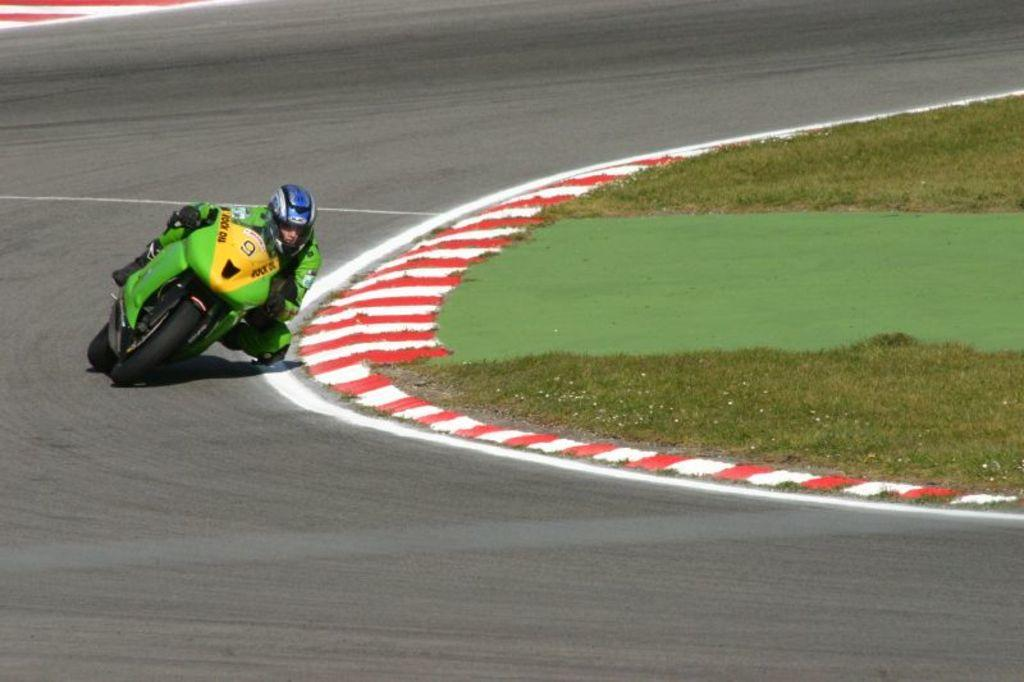What is the person in the image doing? The person is riding a motorcycle in the image. What protective gear is the person wearing? The person is wearing a helmet and gloves. What type of surface is the motorcycle on? The motorcycle is on the road. What can be seen on the ground in the image? There is grass on the ground. How many sheep are visible in the image? There are no sheep present in the image. Is the motorcycle riding up a slope in the image? The image does not show the motorcycle riding up a slope; it is on a flat road. 